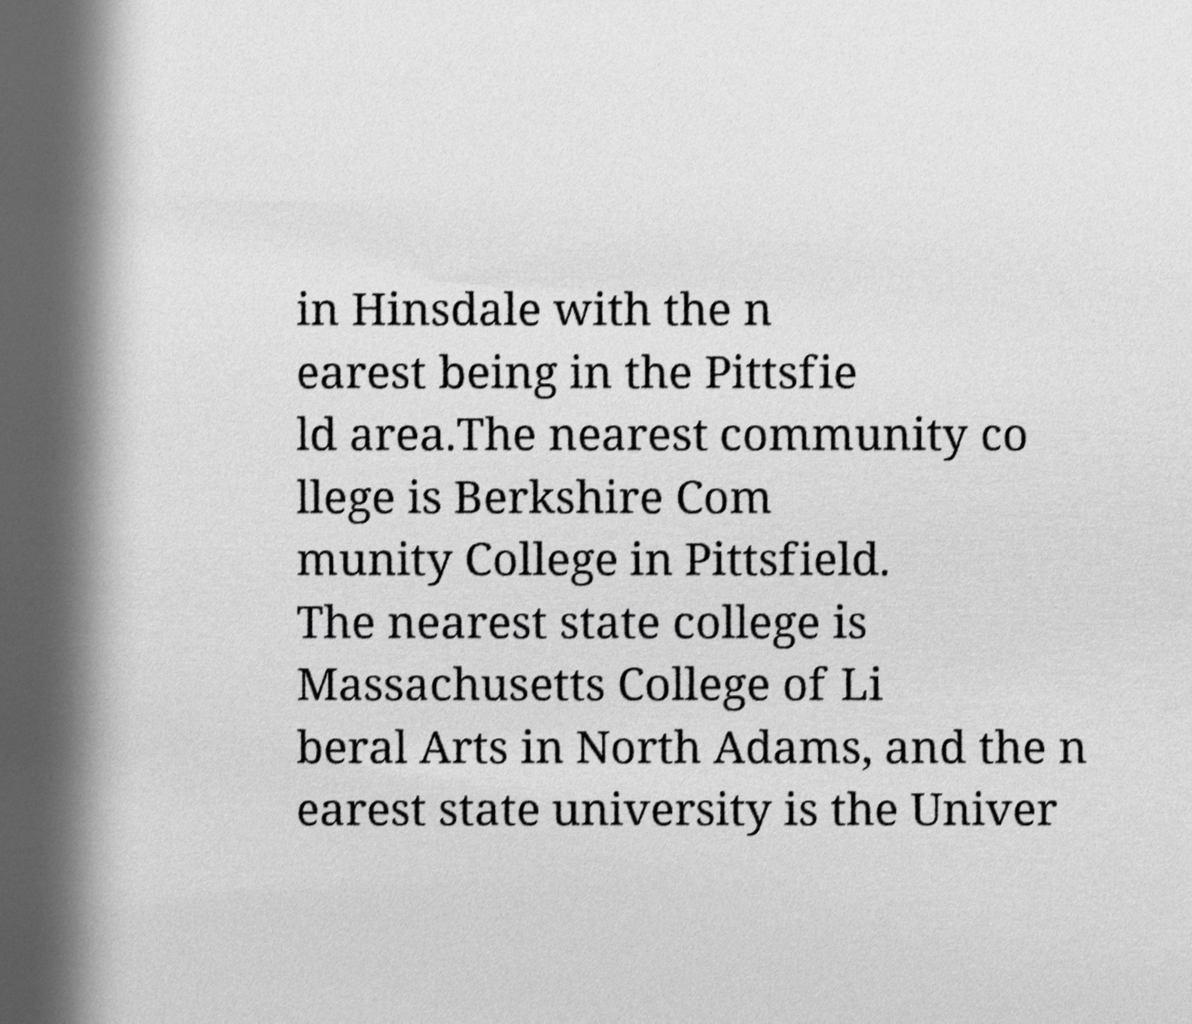Can you accurately transcribe the text from the provided image for me? in Hinsdale with the n earest being in the Pittsfie ld area.The nearest community co llege is Berkshire Com munity College in Pittsfield. The nearest state college is Massachusetts College of Li beral Arts in North Adams, and the n earest state university is the Univer 